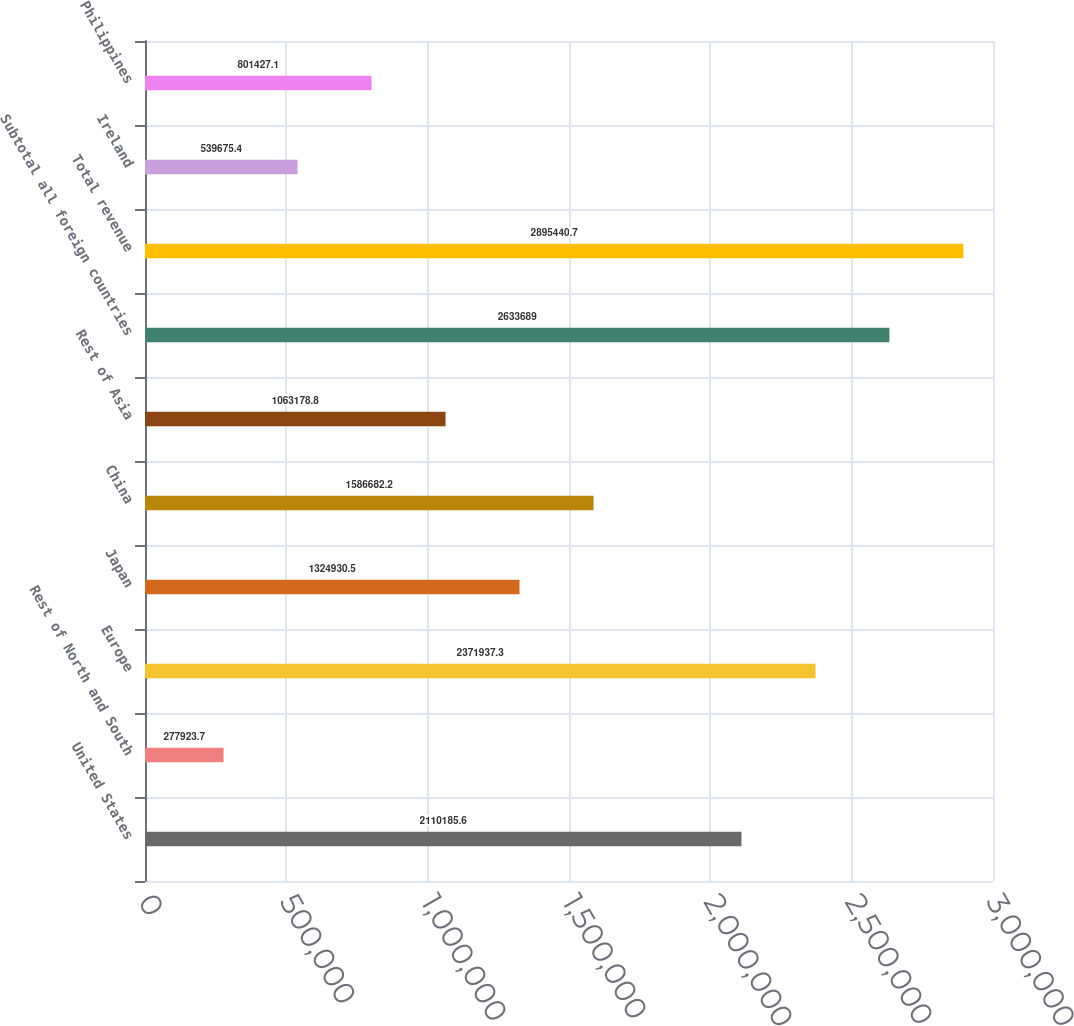Convert chart. <chart><loc_0><loc_0><loc_500><loc_500><bar_chart><fcel>United States<fcel>Rest of North and South<fcel>Europe<fcel>Japan<fcel>China<fcel>Rest of Asia<fcel>Subtotal all foreign countries<fcel>Total revenue<fcel>Ireland<fcel>Philippines<nl><fcel>2.11019e+06<fcel>277924<fcel>2.37194e+06<fcel>1.32493e+06<fcel>1.58668e+06<fcel>1.06318e+06<fcel>2.63369e+06<fcel>2.89544e+06<fcel>539675<fcel>801427<nl></chart> 